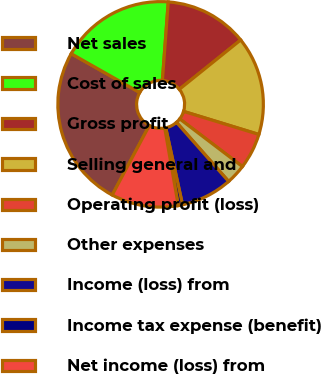<chart> <loc_0><loc_0><loc_500><loc_500><pie_chart><fcel>Net sales<fcel>Cost of sales<fcel>Gross profit<fcel>Selling general and<fcel>Operating profit (loss)<fcel>Other expenses<fcel>Income (loss) from<fcel>Income tax expense (benefit)<fcel>Net income (loss) from<nl><fcel>25.4%<fcel>17.98%<fcel>13.03%<fcel>15.51%<fcel>5.62%<fcel>3.14%<fcel>8.09%<fcel>0.67%<fcel>10.56%<nl></chart> 